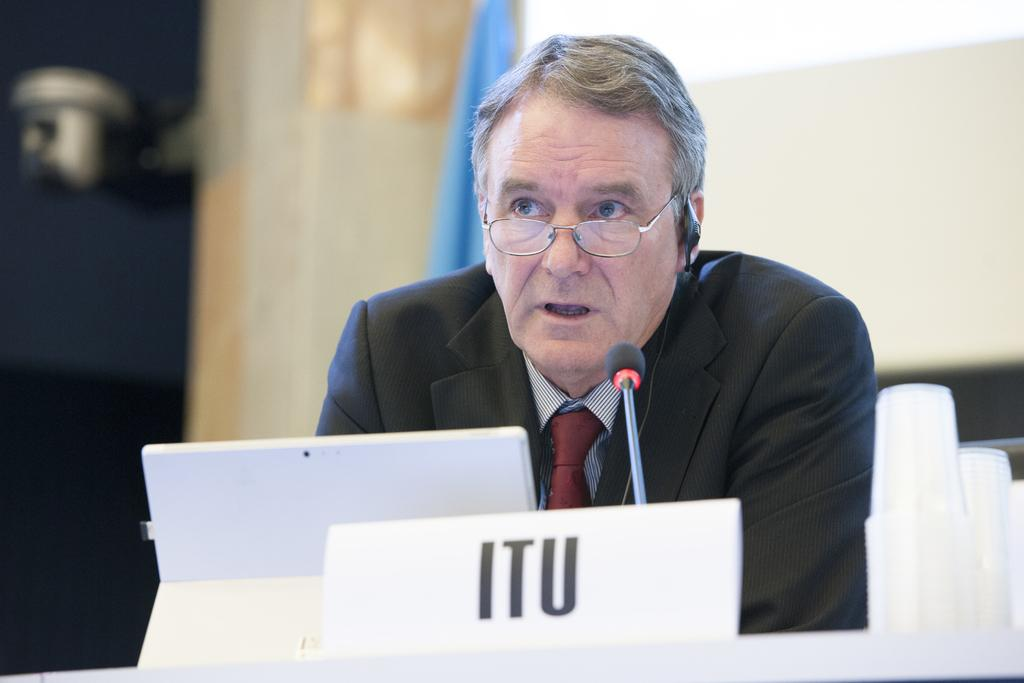What is the man doing in the image? The man is standing at a podium in the image. What device is present in the image that might be used for presenting information? There is a laptop in the image. What is the man using to amplify his voice in the image? There is a microphone in the image. What can be seen on the man's face in the image? The man is wearing spectacles in the image. What item is visible in the image that might be used for drinking or eating? There are glasses visible in the image. What type of fiction is the man reading from the laptop in the image? There is no indication in the image that the man is reading fiction from the laptop. 